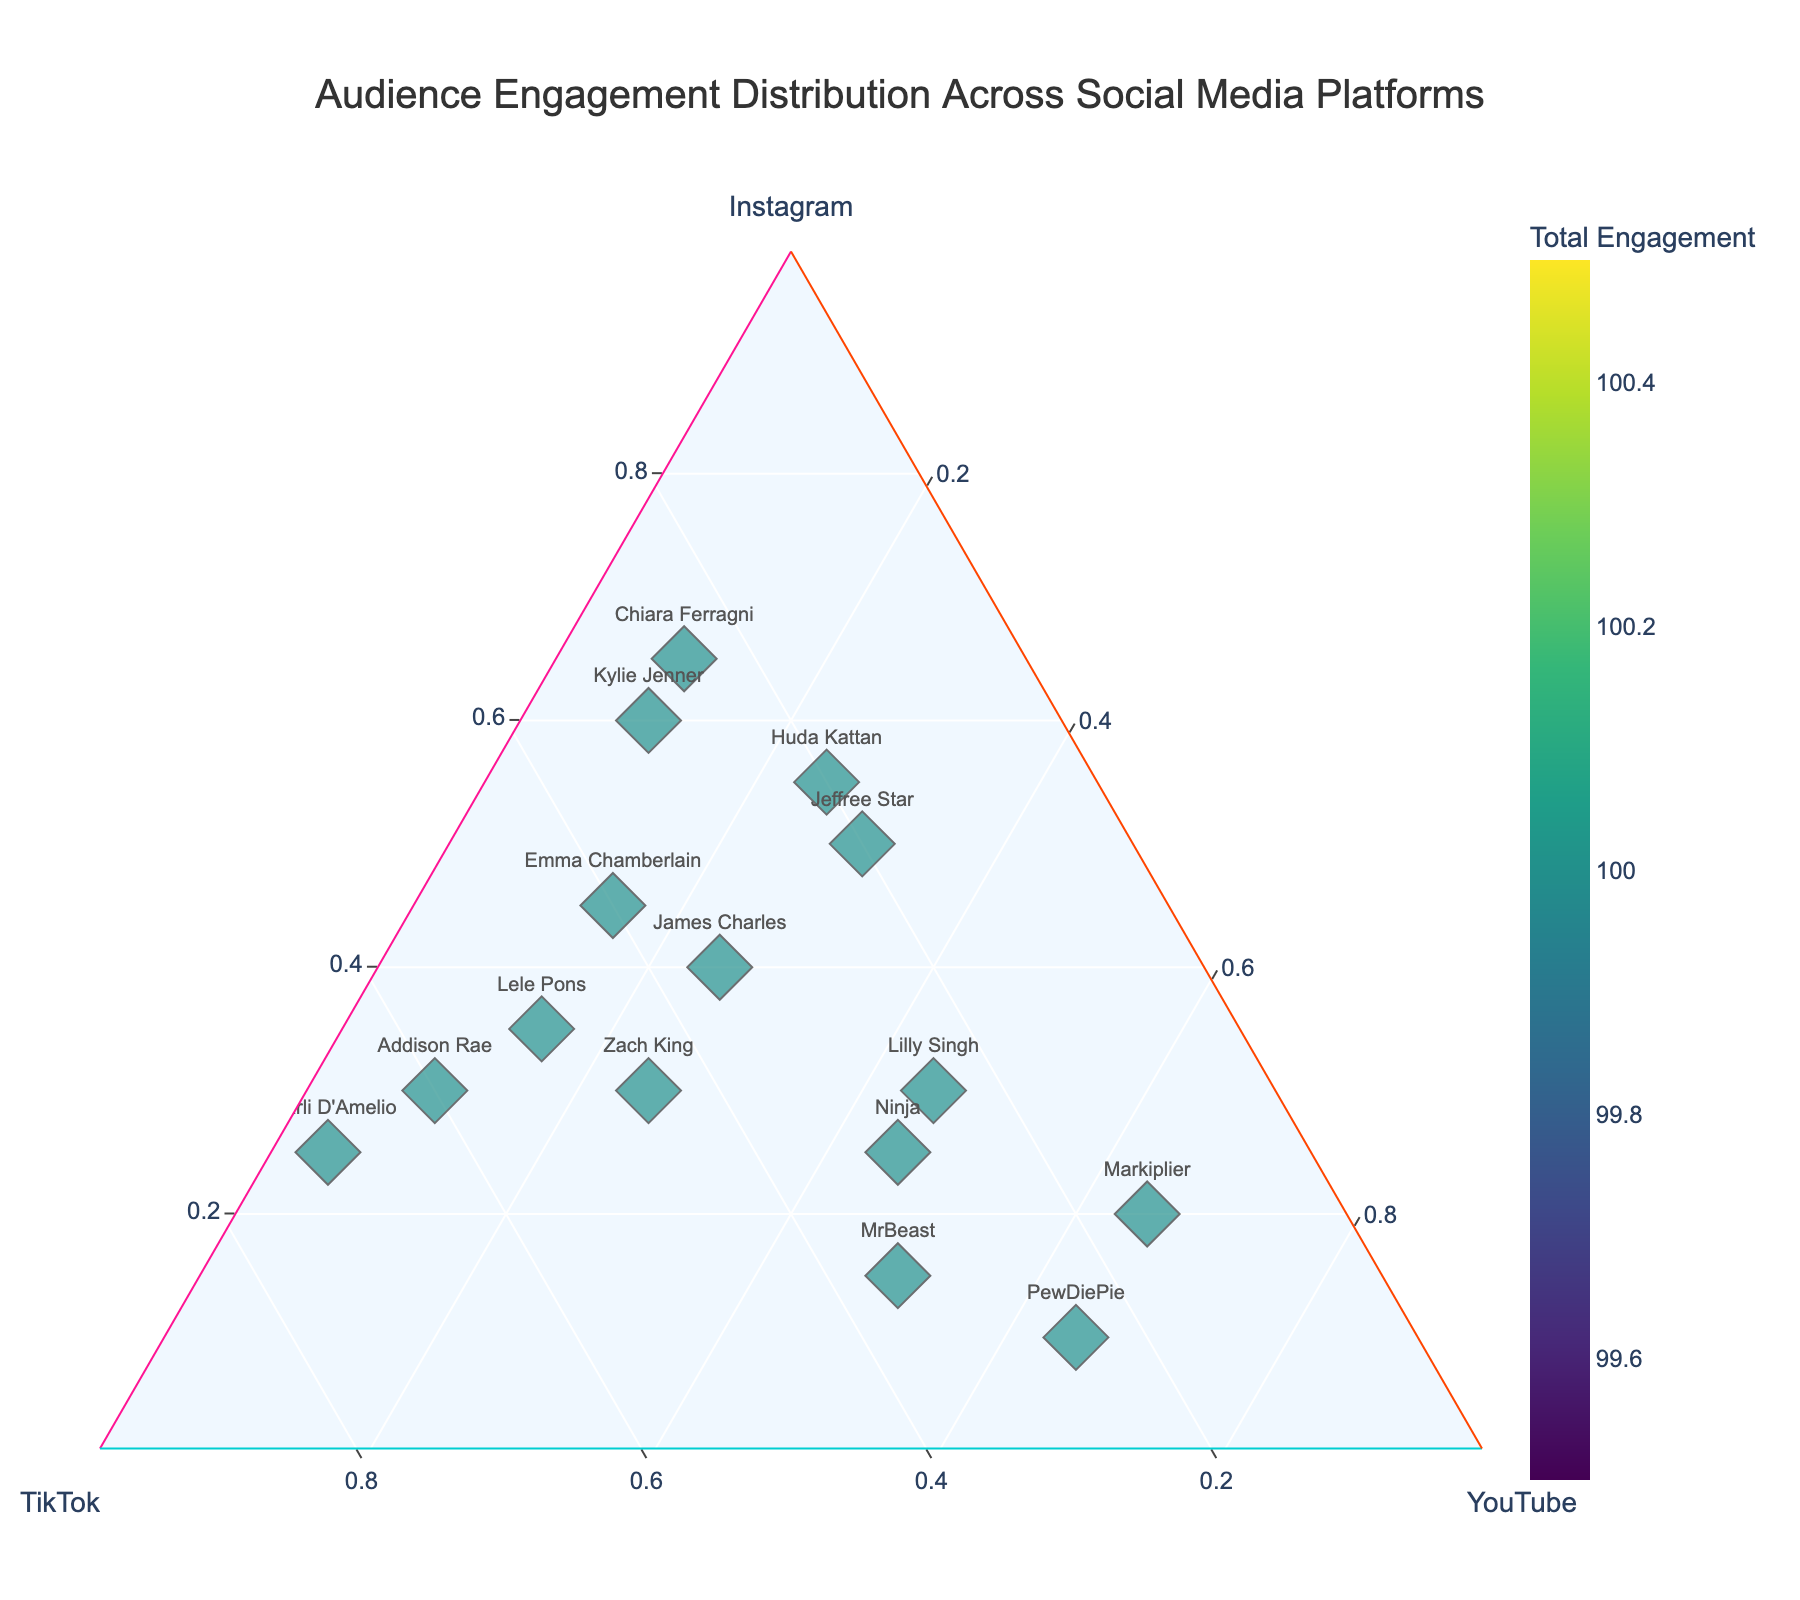What's the title of the plot? The title of the plot is located at the top center of the figure. It should be the most prominent text in the layout.
Answer: Audience Engagement Distribution Across Social Media Platforms How many influencers have TikTok as their dominant platform? Look at the points that are positioned closer to the TikTok axis (usually represented by a larger proportion on the bottom right side). Count these points.
Answer: 4 (Charli D'Amelio, Lele Pons, Addison Rae, Zach King) Which influencer has the highest total engagement? Look at the size of the markers on the plot, as they represent the total engagement. The largest marker corresponds to the highest total engagement.
Answer: MrBeast Who has a balanced audience distribution across Instagram, TikTok, and YouTube? Check the points that are positioned near the center of the ternary plot, indicating that the distribution is relatively balanced across all three platforms.
Answer: Lilly Singh Which influencer is closest to the Instagram axis? Identify the point that is closest to the Instagram apex of the ternary plot, meaning the highest value for Instagram in relative terms.
Answer: Chiara Ferragni Which influencers have higher YouTube engagement than Instagram engagement? Compare the positions of the points relative to the YouTube and Instagram axes. Points closer to the YouTube side than the Instagram side indicate higher YouTube engagement.
Answer: PewDiePie, MrBeast, Markiplier How does PewDiePie's engagement on Facebook compare to his engagement on Instagram and TikTok? Compare the positioning of PewDiePie's point on the ternary plot. PewDiePie's position is farthest from the TikTok and Instagram axes, indicating higher YouTube engagement.
Answer: Higher engagement on YouTube, lower on Instagram and TikTok What is the combined percentage of engagement for Huda Kattan on Instagram and TikTok? Identify Huda Kattan's position on the ternary plot and sum the percentages for Instagram and TikTok from the axes. Engagement on Instagram is 55% and TikTok is 20%. Combined percentage = 55% + 20% = 75%.
Answer: 75% Who has the highest engagement on YouTube? Identify the point closest to the YouTube apex on the ternary plot.
Answer: PewDiePie Between Zach King and Emma Chamberlain, who has a more balanced distribution across the three platforms? Compare the positions of Zach King and Emma Chamberlain on the ternary plot. The more balanced distribution is indicated by a position closer to the center.
Answer: Emma Chamberlain 